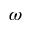<formula> <loc_0><loc_0><loc_500><loc_500>\omega</formula> 